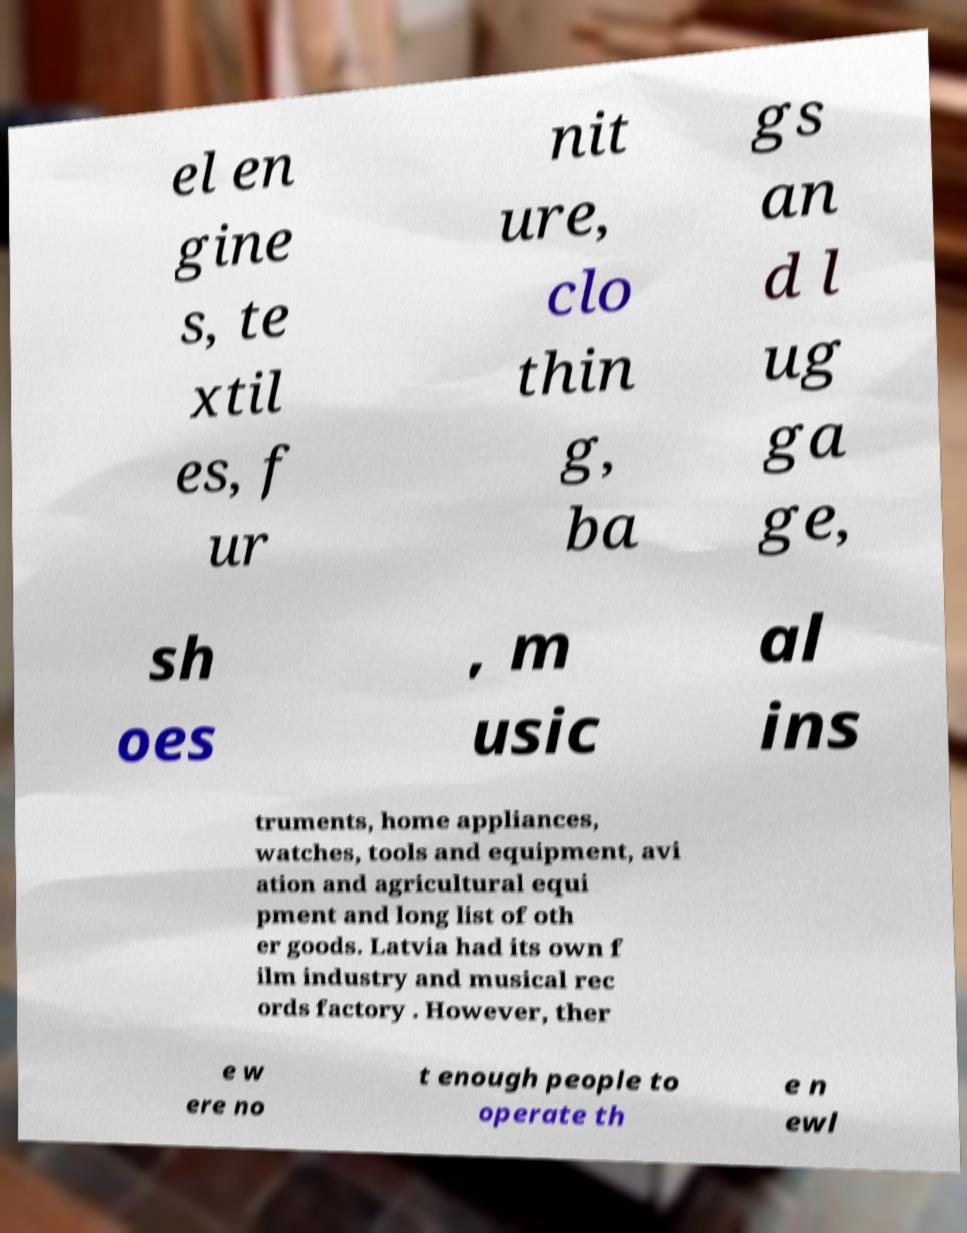Can you read and provide the text displayed in the image?This photo seems to have some interesting text. Can you extract and type it out for me? el en gine s, te xtil es, f ur nit ure, clo thin g, ba gs an d l ug ga ge, sh oes , m usic al ins truments, home appliances, watches, tools and equipment, avi ation and agricultural equi pment and long list of oth er goods. Latvia had its own f ilm industry and musical rec ords factory . However, ther e w ere no t enough people to operate th e n ewl 